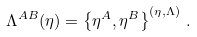<formula> <loc_0><loc_0><loc_500><loc_500>\Lambda ^ { A B } ( \eta ) = \left \{ \eta ^ { A } , \eta ^ { B } \right \} ^ { ( \eta , \Lambda ) } \, .</formula> 